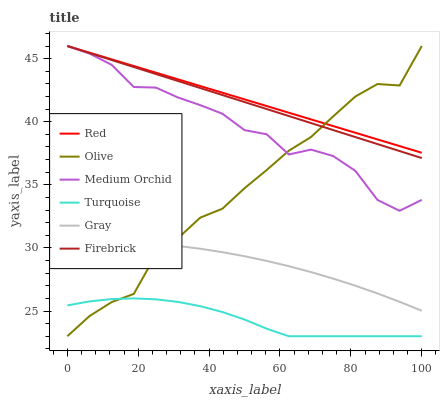Does Turquoise have the minimum area under the curve?
Answer yes or no. Yes. Does Red have the maximum area under the curve?
Answer yes or no. Yes. Does Firebrick have the minimum area under the curve?
Answer yes or no. No. Does Firebrick have the maximum area under the curve?
Answer yes or no. No. Is Red the smoothest?
Answer yes or no. Yes. Is Medium Orchid the roughest?
Answer yes or no. Yes. Is Turquoise the smoothest?
Answer yes or no. No. Is Turquoise the roughest?
Answer yes or no. No. Does Turquoise have the lowest value?
Answer yes or no. Yes. Does Firebrick have the lowest value?
Answer yes or no. No. Does Red have the highest value?
Answer yes or no. Yes. Does Turquoise have the highest value?
Answer yes or no. No. Is Turquoise less than Red?
Answer yes or no. Yes. Is Medium Orchid greater than Gray?
Answer yes or no. Yes. Does Medium Orchid intersect Red?
Answer yes or no. Yes. Is Medium Orchid less than Red?
Answer yes or no. No. Is Medium Orchid greater than Red?
Answer yes or no. No. Does Turquoise intersect Red?
Answer yes or no. No. 